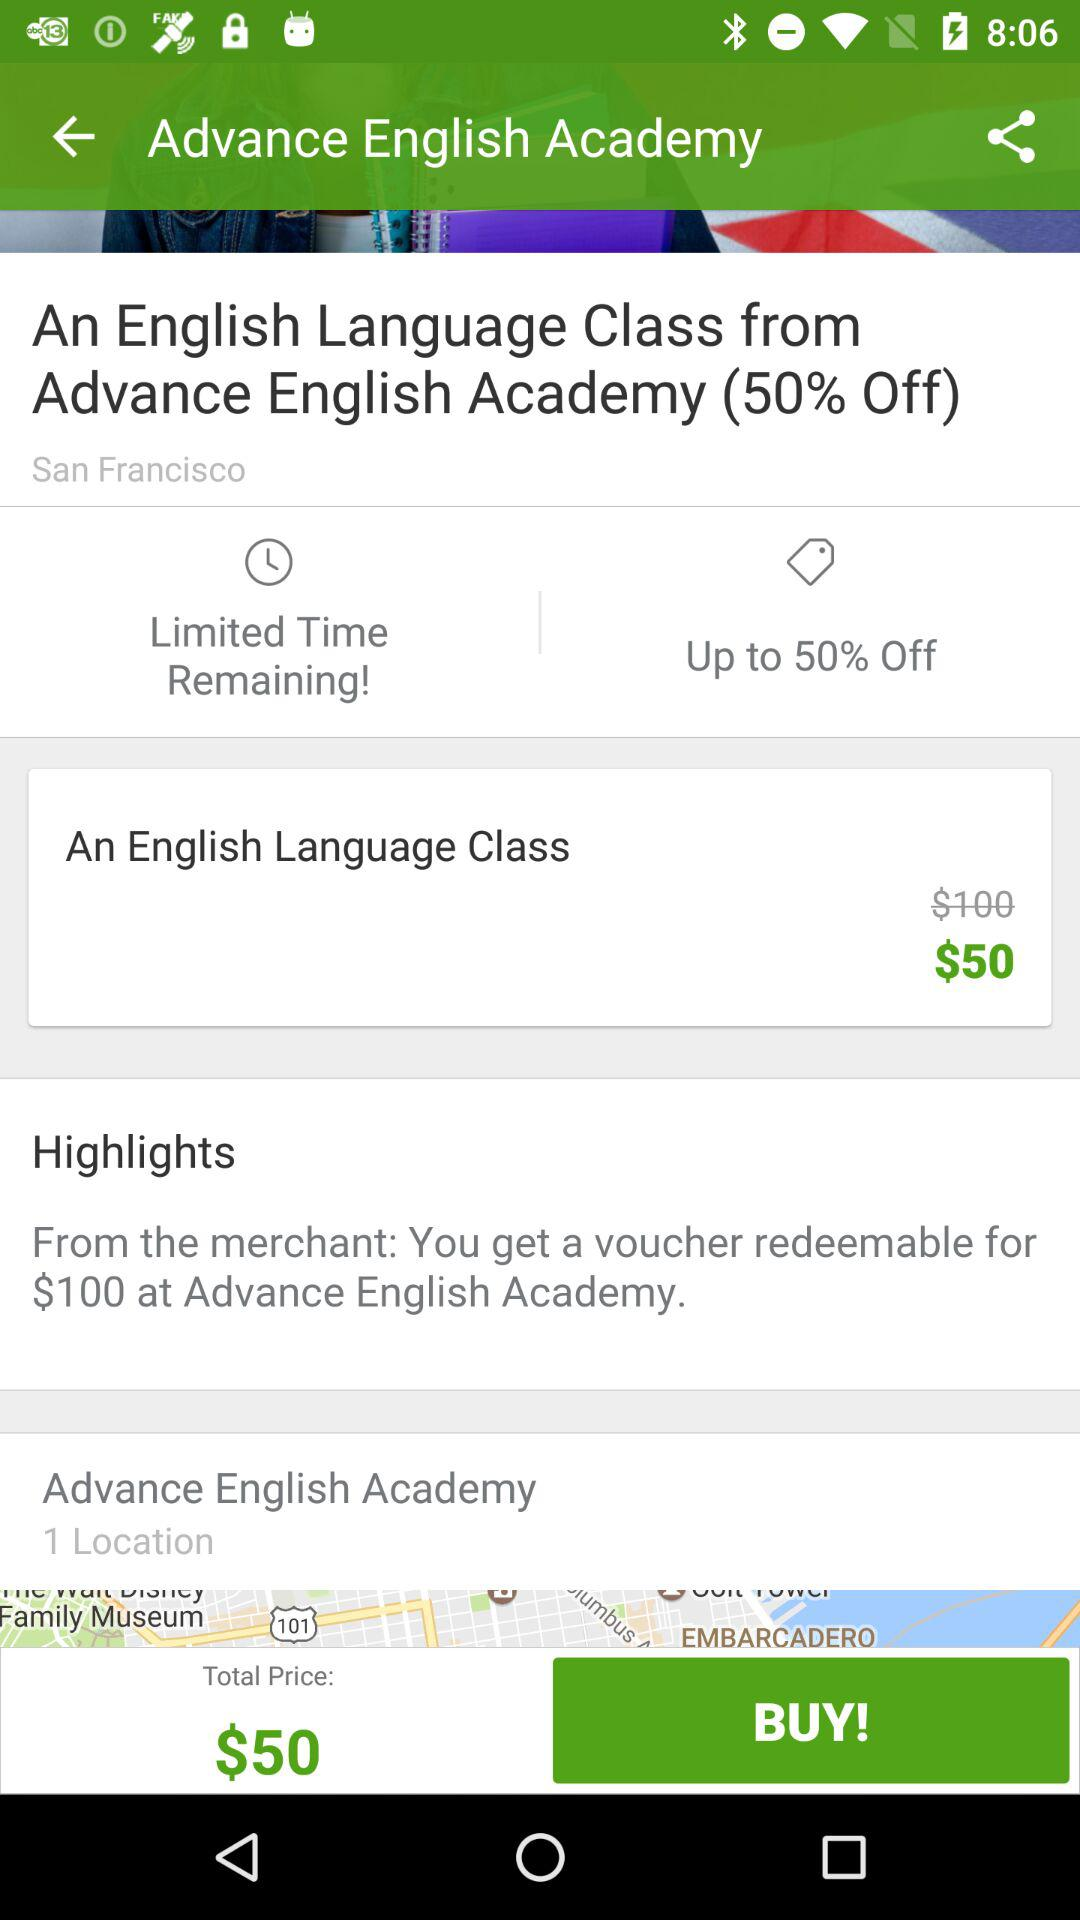What is the cost of an English language class? The cost is $50. 